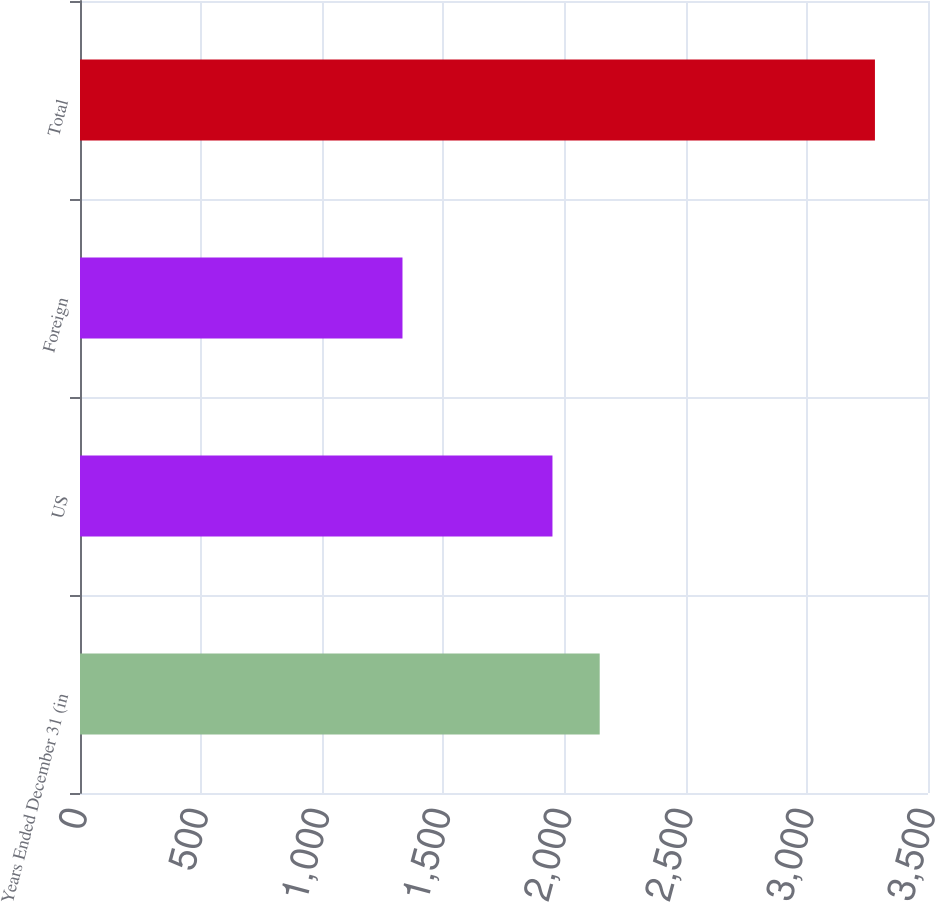Convert chart. <chart><loc_0><loc_0><loc_500><loc_500><bar_chart><fcel>Years Ended December 31 (in<fcel>US<fcel>Foreign<fcel>Total<nl><fcel>2145<fcel>1950<fcel>1331<fcel>3281<nl></chart> 